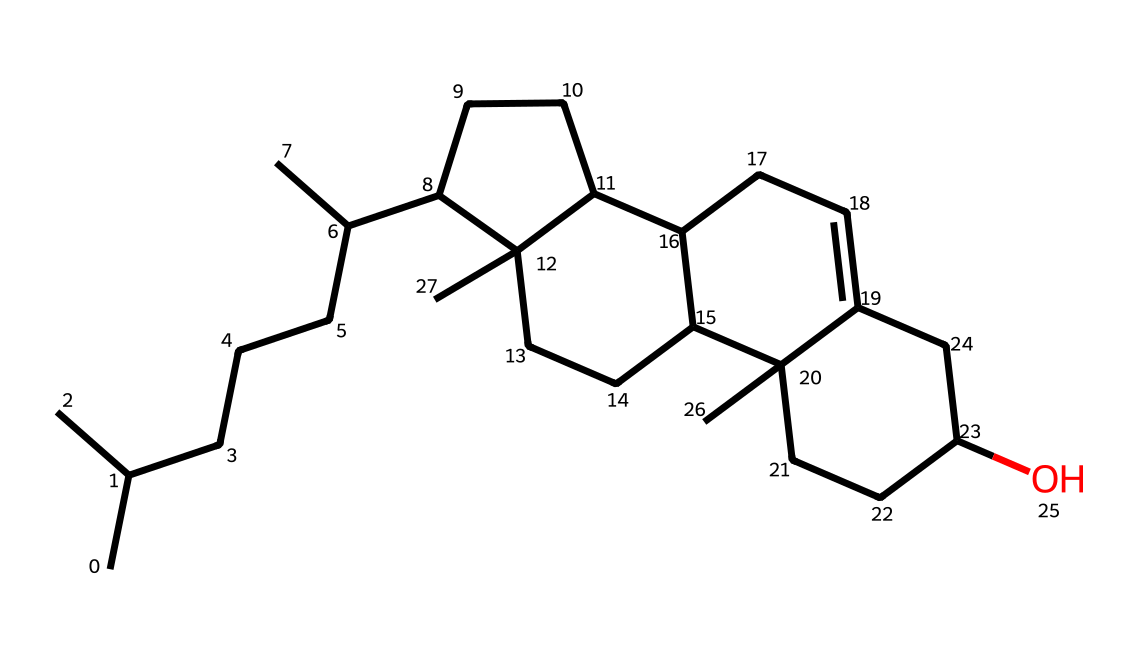What is the molecular formula of cholesterol? The SMILES representation indicates the number of carbon (C), hydrogen (H), and oxygen (O) atoms by counting them in the structure. The result is C27H46O.
Answer: C27H46O How many rings are present in the structure of cholesterol? By analyzing the chemical structure, we can identify that there are four fused rings (the sterol structure) present in cholesterol.
Answer: four What is the primary functional group in cholesterol? Looking closely at the structural formula, one can observe that there is a hydroxyl (–OH) group attached, which is characteristic of alcohols.
Answer: hydroxyl How many carbon atoms are in the longest carbon chain of cholesterol? The longest continuous chain of carbon atoms in the structure can be traced, which shows a straight chain of 8 carbon atoms.
Answer: eight Does cholesterol contain unsaturated bonds? Inspection of the chemical structure reveals there is a double bond evident in one of the rings, indicating the presence of unsaturation.
Answer: yes What type of lipid is cholesterol categorized as? Cholesterol is specifically categorized as a sterol due to its distinct multi-ring structure and its role in cellular membranes.
Answer: sterol 